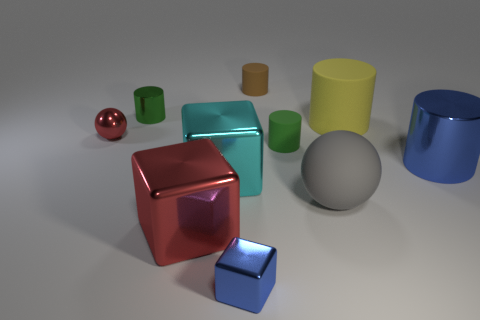Subtract 1 cylinders. How many cylinders are left? 4 Subtract all yellow cylinders. How many cylinders are left? 4 Subtract all large yellow rubber cylinders. How many cylinders are left? 4 Subtract all cyan cylinders. Subtract all gray balls. How many cylinders are left? 5 Subtract all blocks. How many objects are left? 7 Subtract 0 purple balls. How many objects are left? 10 Subtract all large blue balls. Subtract all large blue cylinders. How many objects are left? 9 Add 4 green cylinders. How many green cylinders are left? 6 Add 4 yellow cylinders. How many yellow cylinders exist? 5 